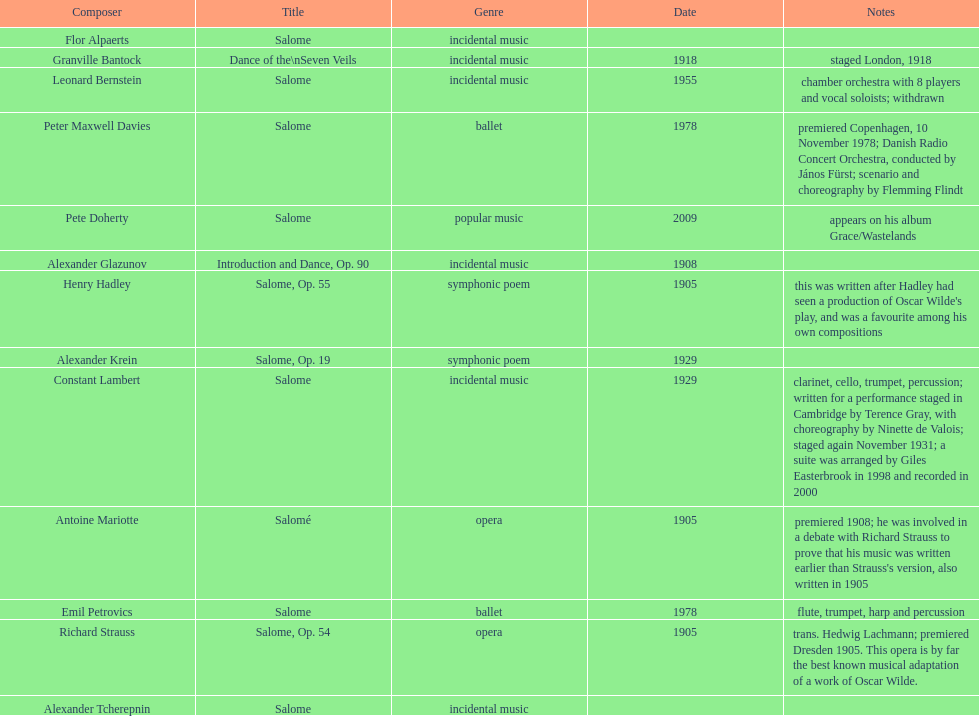Who is on top of the list? Flor Alpaerts. 